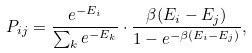Convert formula to latex. <formula><loc_0><loc_0><loc_500><loc_500>P _ { i j } = \frac { e ^ { - E _ { i } } } { \sum _ { k } e ^ { - E _ { k } } } \cdot \frac { \beta ( E _ { i } - E _ { j } ) } { 1 - e ^ { - \beta ( E _ { i } - E _ { j } ) } } ,</formula> 